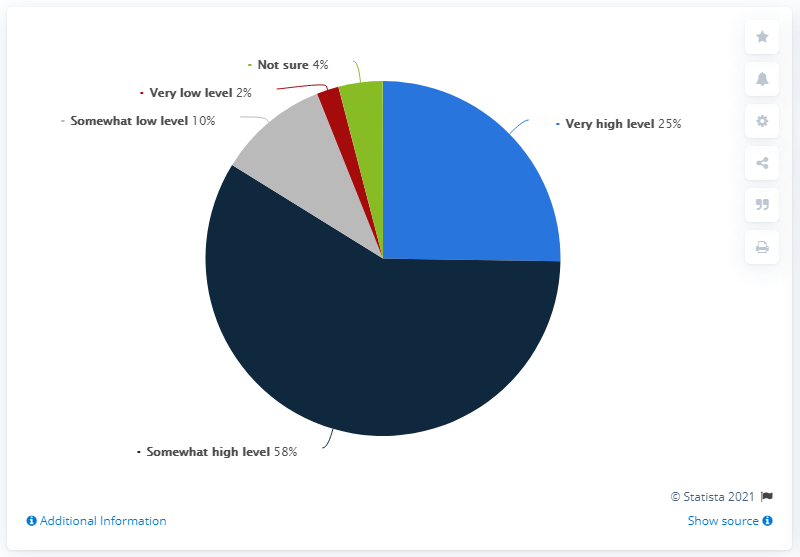List a handful of essential elements in this visual. The sum of green, red, and grey is 16. The value being referred to is greater than 50%, which can be considered somewhat high. 